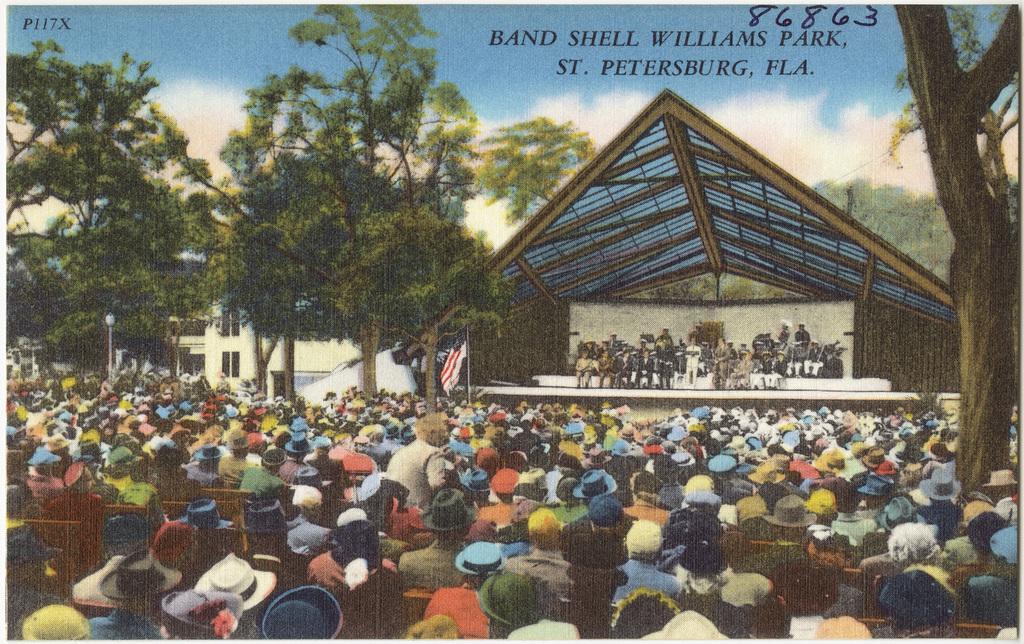Describe this image in one or two sentences. This image is consists of a poster, in which there are people those who are sitting at the bottom side of the image and there is a stage in front of them, there is a flag in the center of the image and there are trees and buildings in the background area of the image. 